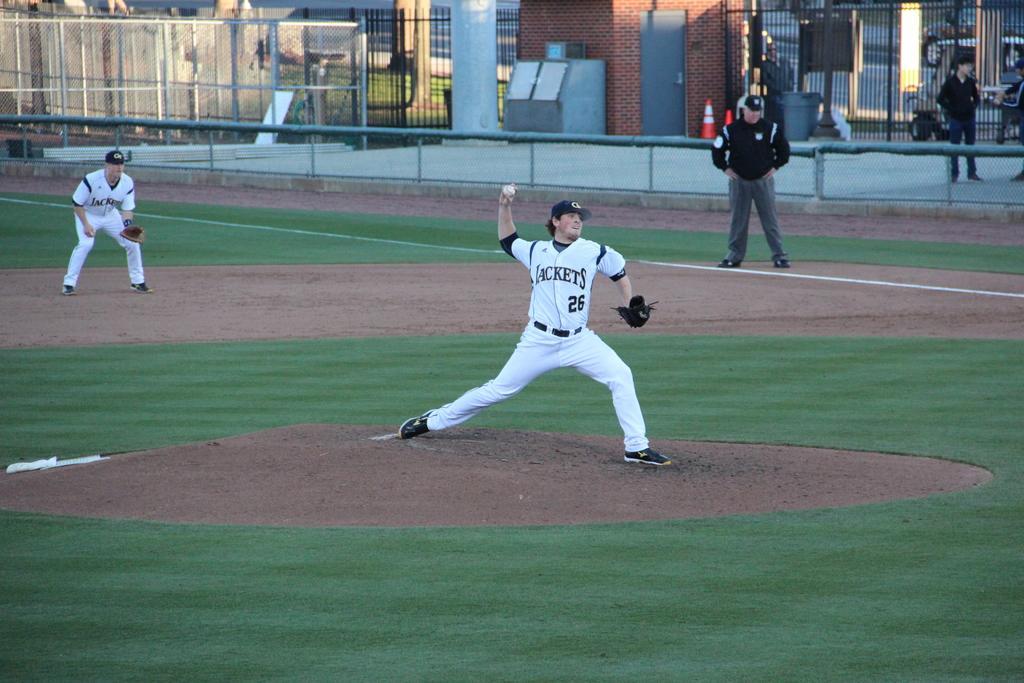How would you summarize this image in a sentence or two? In this picture I can see there is a person standing here and there are two more people standing here and in the backdrop there is a fence, road. 